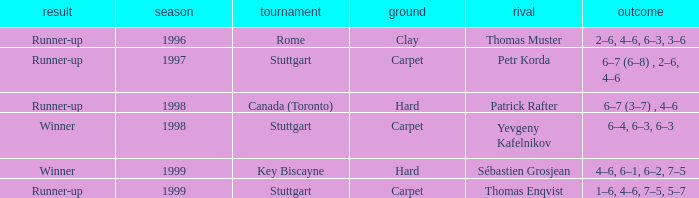What was the surface in 1996? Clay. 